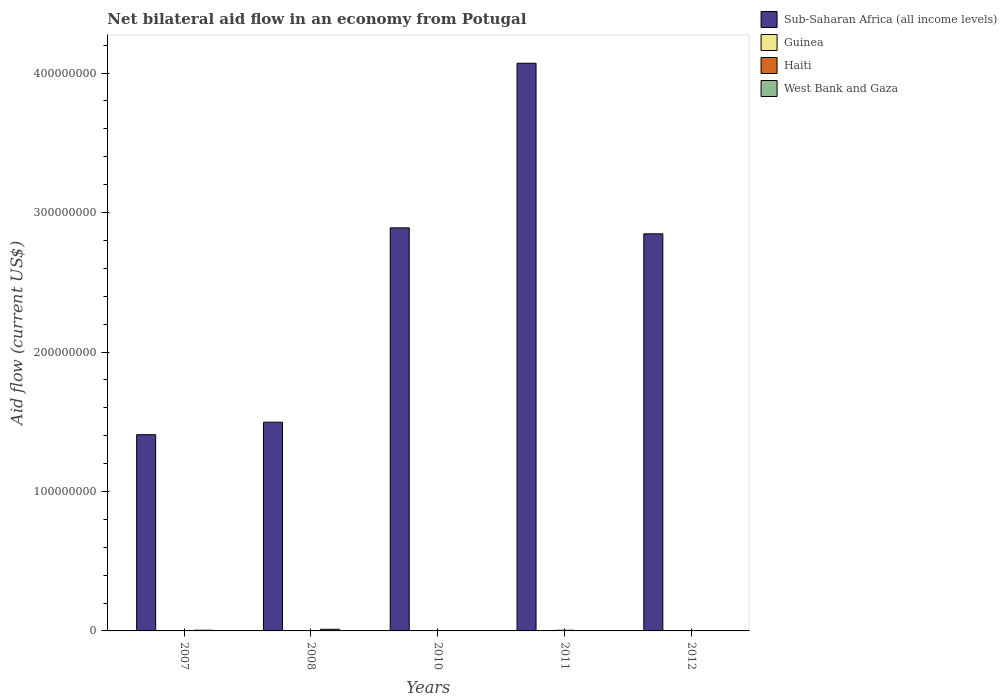How many different coloured bars are there?
Your answer should be very brief. 4. What is the label of the 3rd group of bars from the left?
Your response must be concise. 2010. In how many cases, is the number of bars for a given year not equal to the number of legend labels?
Give a very brief answer. 0. What is the net bilateral aid flow in Guinea in 2010?
Make the answer very short. 4.00e+04. Across all years, what is the minimum net bilateral aid flow in Sub-Saharan Africa (all income levels)?
Offer a terse response. 1.41e+08. In which year was the net bilateral aid flow in West Bank and Gaza minimum?
Ensure brevity in your answer.  2010. What is the total net bilateral aid flow in Haiti in the graph?
Offer a terse response. 9.40e+05. What is the difference between the net bilateral aid flow in Sub-Saharan Africa (all income levels) in 2011 and that in 2012?
Provide a succinct answer. 1.22e+08. What is the difference between the net bilateral aid flow in Haiti in 2011 and the net bilateral aid flow in Sub-Saharan Africa (all income levels) in 2010?
Provide a short and direct response. -2.89e+08. What is the average net bilateral aid flow in Haiti per year?
Offer a very short reply. 1.88e+05. In the year 2010, what is the difference between the net bilateral aid flow in Guinea and net bilateral aid flow in Sub-Saharan Africa (all income levels)?
Provide a succinct answer. -2.89e+08. In how many years, is the net bilateral aid flow in Sub-Saharan Africa (all income levels) greater than 200000000 US$?
Make the answer very short. 3. What is the ratio of the net bilateral aid flow in Guinea in 2010 to that in 2011?
Keep it short and to the point. 0.31. Is the net bilateral aid flow in Guinea in 2007 less than that in 2012?
Offer a terse response. Yes. Is the difference between the net bilateral aid flow in Guinea in 2008 and 2011 greater than the difference between the net bilateral aid flow in Sub-Saharan Africa (all income levels) in 2008 and 2011?
Give a very brief answer. Yes. What is the difference between the highest and the second highest net bilateral aid flow in Guinea?
Offer a terse response. 5.00e+04. What is the difference between the highest and the lowest net bilateral aid flow in West Bank and Gaza?
Keep it short and to the point. 1.18e+06. In how many years, is the net bilateral aid flow in Sub-Saharan Africa (all income levels) greater than the average net bilateral aid flow in Sub-Saharan Africa (all income levels) taken over all years?
Give a very brief answer. 3. Is it the case that in every year, the sum of the net bilateral aid flow in Guinea and net bilateral aid flow in West Bank and Gaza is greater than the sum of net bilateral aid flow in Sub-Saharan Africa (all income levels) and net bilateral aid flow in Haiti?
Ensure brevity in your answer.  No. What does the 1st bar from the left in 2011 represents?
Give a very brief answer. Sub-Saharan Africa (all income levels). What does the 2nd bar from the right in 2010 represents?
Provide a short and direct response. Haiti. Is it the case that in every year, the sum of the net bilateral aid flow in Haiti and net bilateral aid flow in West Bank and Gaza is greater than the net bilateral aid flow in Sub-Saharan Africa (all income levels)?
Make the answer very short. No. How many bars are there?
Your response must be concise. 20. Are all the bars in the graph horizontal?
Offer a very short reply. No. Are the values on the major ticks of Y-axis written in scientific E-notation?
Keep it short and to the point. No. Where does the legend appear in the graph?
Your answer should be very brief. Top right. What is the title of the graph?
Give a very brief answer. Net bilateral aid flow in an economy from Potugal. What is the label or title of the Y-axis?
Make the answer very short. Aid flow (current US$). What is the Aid flow (current US$) in Sub-Saharan Africa (all income levels) in 2007?
Offer a very short reply. 1.41e+08. What is the Aid flow (current US$) of Guinea in 2007?
Your response must be concise. 8.00e+04. What is the Aid flow (current US$) in Haiti in 2007?
Your answer should be compact. 1.70e+05. What is the Aid flow (current US$) of West Bank and Gaza in 2007?
Your response must be concise. 4.90e+05. What is the Aid flow (current US$) in Sub-Saharan Africa (all income levels) in 2008?
Offer a very short reply. 1.50e+08. What is the Aid flow (current US$) of Guinea in 2008?
Offer a very short reply. 4.00e+04. What is the Aid flow (current US$) in West Bank and Gaza in 2008?
Keep it short and to the point. 1.19e+06. What is the Aid flow (current US$) of Sub-Saharan Africa (all income levels) in 2010?
Provide a short and direct response. 2.89e+08. What is the Aid flow (current US$) of Sub-Saharan Africa (all income levels) in 2011?
Your answer should be compact. 4.07e+08. What is the Aid flow (current US$) in Haiti in 2011?
Offer a very short reply. 4.70e+05. What is the Aid flow (current US$) in West Bank and Gaza in 2011?
Offer a terse response. 2.00e+04. What is the Aid flow (current US$) in Sub-Saharan Africa (all income levels) in 2012?
Provide a succinct answer. 2.85e+08. What is the Aid flow (current US$) of Guinea in 2012?
Your answer should be compact. 1.80e+05. What is the Aid flow (current US$) in Haiti in 2012?
Give a very brief answer. 10000. What is the Aid flow (current US$) of West Bank and Gaza in 2012?
Offer a very short reply. 10000. Across all years, what is the maximum Aid flow (current US$) of Sub-Saharan Africa (all income levels)?
Offer a terse response. 4.07e+08. Across all years, what is the maximum Aid flow (current US$) of Guinea?
Ensure brevity in your answer.  1.80e+05. Across all years, what is the maximum Aid flow (current US$) of West Bank and Gaza?
Give a very brief answer. 1.19e+06. Across all years, what is the minimum Aid flow (current US$) in Sub-Saharan Africa (all income levels)?
Provide a short and direct response. 1.41e+08. Across all years, what is the minimum Aid flow (current US$) in Guinea?
Provide a succinct answer. 4.00e+04. Across all years, what is the minimum Aid flow (current US$) in Haiti?
Offer a terse response. 10000. Across all years, what is the minimum Aid flow (current US$) in West Bank and Gaza?
Your response must be concise. 10000. What is the total Aid flow (current US$) of Sub-Saharan Africa (all income levels) in the graph?
Provide a succinct answer. 1.27e+09. What is the total Aid flow (current US$) in Guinea in the graph?
Provide a short and direct response. 4.70e+05. What is the total Aid flow (current US$) in Haiti in the graph?
Give a very brief answer. 9.40e+05. What is the total Aid flow (current US$) of West Bank and Gaza in the graph?
Your answer should be compact. 1.72e+06. What is the difference between the Aid flow (current US$) of Sub-Saharan Africa (all income levels) in 2007 and that in 2008?
Give a very brief answer. -8.95e+06. What is the difference between the Aid flow (current US$) of Guinea in 2007 and that in 2008?
Your answer should be very brief. 4.00e+04. What is the difference between the Aid flow (current US$) of West Bank and Gaza in 2007 and that in 2008?
Your response must be concise. -7.00e+05. What is the difference between the Aid flow (current US$) of Sub-Saharan Africa (all income levels) in 2007 and that in 2010?
Give a very brief answer. -1.48e+08. What is the difference between the Aid flow (current US$) of Guinea in 2007 and that in 2010?
Make the answer very short. 4.00e+04. What is the difference between the Aid flow (current US$) in Sub-Saharan Africa (all income levels) in 2007 and that in 2011?
Offer a very short reply. -2.66e+08. What is the difference between the Aid flow (current US$) in West Bank and Gaza in 2007 and that in 2011?
Ensure brevity in your answer.  4.70e+05. What is the difference between the Aid flow (current US$) in Sub-Saharan Africa (all income levels) in 2007 and that in 2012?
Your answer should be compact. -1.44e+08. What is the difference between the Aid flow (current US$) in Haiti in 2007 and that in 2012?
Keep it short and to the point. 1.60e+05. What is the difference between the Aid flow (current US$) in Sub-Saharan Africa (all income levels) in 2008 and that in 2010?
Ensure brevity in your answer.  -1.39e+08. What is the difference between the Aid flow (current US$) of Guinea in 2008 and that in 2010?
Make the answer very short. 0. What is the difference between the Aid flow (current US$) in Haiti in 2008 and that in 2010?
Provide a short and direct response. 7.00e+04. What is the difference between the Aid flow (current US$) of West Bank and Gaza in 2008 and that in 2010?
Make the answer very short. 1.18e+06. What is the difference between the Aid flow (current US$) of Sub-Saharan Africa (all income levels) in 2008 and that in 2011?
Make the answer very short. -2.57e+08. What is the difference between the Aid flow (current US$) of Haiti in 2008 and that in 2011?
Provide a short and direct response. -2.90e+05. What is the difference between the Aid flow (current US$) in West Bank and Gaza in 2008 and that in 2011?
Offer a very short reply. 1.17e+06. What is the difference between the Aid flow (current US$) in Sub-Saharan Africa (all income levels) in 2008 and that in 2012?
Make the answer very short. -1.35e+08. What is the difference between the Aid flow (current US$) in Guinea in 2008 and that in 2012?
Your response must be concise. -1.40e+05. What is the difference between the Aid flow (current US$) in Haiti in 2008 and that in 2012?
Your answer should be compact. 1.70e+05. What is the difference between the Aid flow (current US$) of West Bank and Gaza in 2008 and that in 2012?
Your answer should be compact. 1.18e+06. What is the difference between the Aid flow (current US$) of Sub-Saharan Africa (all income levels) in 2010 and that in 2011?
Provide a succinct answer. -1.18e+08. What is the difference between the Aid flow (current US$) in Haiti in 2010 and that in 2011?
Make the answer very short. -3.60e+05. What is the difference between the Aid flow (current US$) of West Bank and Gaza in 2010 and that in 2011?
Keep it short and to the point. -10000. What is the difference between the Aid flow (current US$) in Sub-Saharan Africa (all income levels) in 2010 and that in 2012?
Ensure brevity in your answer.  4.27e+06. What is the difference between the Aid flow (current US$) of Haiti in 2010 and that in 2012?
Provide a succinct answer. 1.00e+05. What is the difference between the Aid flow (current US$) of Sub-Saharan Africa (all income levels) in 2011 and that in 2012?
Your answer should be very brief. 1.22e+08. What is the difference between the Aid flow (current US$) of Guinea in 2011 and that in 2012?
Provide a succinct answer. -5.00e+04. What is the difference between the Aid flow (current US$) of Haiti in 2011 and that in 2012?
Your answer should be compact. 4.60e+05. What is the difference between the Aid flow (current US$) in Sub-Saharan Africa (all income levels) in 2007 and the Aid flow (current US$) in Guinea in 2008?
Offer a very short reply. 1.41e+08. What is the difference between the Aid flow (current US$) in Sub-Saharan Africa (all income levels) in 2007 and the Aid flow (current US$) in Haiti in 2008?
Your answer should be very brief. 1.41e+08. What is the difference between the Aid flow (current US$) in Sub-Saharan Africa (all income levels) in 2007 and the Aid flow (current US$) in West Bank and Gaza in 2008?
Offer a terse response. 1.40e+08. What is the difference between the Aid flow (current US$) of Guinea in 2007 and the Aid flow (current US$) of Haiti in 2008?
Offer a terse response. -1.00e+05. What is the difference between the Aid flow (current US$) in Guinea in 2007 and the Aid flow (current US$) in West Bank and Gaza in 2008?
Ensure brevity in your answer.  -1.11e+06. What is the difference between the Aid flow (current US$) of Haiti in 2007 and the Aid flow (current US$) of West Bank and Gaza in 2008?
Provide a short and direct response. -1.02e+06. What is the difference between the Aid flow (current US$) in Sub-Saharan Africa (all income levels) in 2007 and the Aid flow (current US$) in Guinea in 2010?
Give a very brief answer. 1.41e+08. What is the difference between the Aid flow (current US$) of Sub-Saharan Africa (all income levels) in 2007 and the Aid flow (current US$) of Haiti in 2010?
Your answer should be compact. 1.41e+08. What is the difference between the Aid flow (current US$) in Sub-Saharan Africa (all income levels) in 2007 and the Aid flow (current US$) in West Bank and Gaza in 2010?
Make the answer very short. 1.41e+08. What is the difference between the Aid flow (current US$) of Guinea in 2007 and the Aid flow (current US$) of Haiti in 2010?
Offer a very short reply. -3.00e+04. What is the difference between the Aid flow (current US$) of Sub-Saharan Africa (all income levels) in 2007 and the Aid flow (current US$) of Guinea in 2011?
Your answer should be compact. 1.41e+08. What is the difference between the Aid flow (current US$) of Sub-Saharan Africa (all income levels) in 2007 and the Aid flow (current US$) of Haiti in 2011?
Provide a short and direct response. 1.40e+08. What is the difference between the Aid flow (current US$) of Sub-Saharan Africa (all income levels) in 2007 and the Aid flow (current US$) of West Bank and Gaza in 2011?
Give a very brief answer. 1.41e+08. What is the difference between the Aid flow (current US$) in Guinea in 2007 and the Aid flow (current US$) in Haiti in 2011?
Ensure brevity in your answer.  -3.90e+05. What is the difference between the Aid flow (current US$) of Guinea in 2007 and the Aid flow (current US$) of West Bank and Gaza in 2011?
Offer a terse response. 6.00e+04. What is the difference between the Aid flow (current US$) of Sub-Saharan Africa (all income levels) in 2007 and the Aid flow (current US$) of Guinea in 2012?
Your response must be concise. 1.41e+08. What is the difference between the Aid flow (current US$) in Sub-Saharan Africa (all income levels) in 2007 and the Aid flow (current US$) in Haiti in 2012?
Your answer should be very brief. 1.41e+08. What is the difference between the Aid flow (current US$) of Sub-Saharan Africa (all income levels) in 2007 and the Aid flow (current US$) of West Bank and Gaza in 2012?
Offer a very short reply. 1.41e+08. What is the difference between the Aid flow (current US$) of Guinea in 2007 and the Aid flow (current US$) of Haiti in 2012?
Give a very brief answer. 7.00e+04. What is the difference between the Aid flow (current US$) in Haiti in 2007 and the Aid flow (current US$) in West Bank and Gaza in 2012?
Offer a very short reply. 1.60e+05. What is the difference between the Aid flow (current US$) in Sub-Saharan Africa (all income levels) in 2008 and the Aid flow (current US$) in Guinea in 2010?
Provide a succinct answer. 1.50e+08. What is the difference between the Aid flow (current US$) in Sub-Saharan Africa (all income levels) in 2008 and the Aid flow (current US$) in Haiti in 2010?
Ensure brevity in your answer.  1.50e+08. What is the difference between the Aid flow (current US$) in Sub-Saharan Africa (all income levels) in 2008 and the Aid flow (current US$) in West Bank and Gaza in 2010?
Your answer should be compact. 1.50e+08. What is the difference between the Aid flow (current US$) in Guinea in 2008 and the Aid flow (current US$) in West Bank and Gaza in 2010?
Your answer should be very brief. 3.00e+04. What is the difference between the Aid flow (current US$) of Sub-Saharan Africa (all income levels) in 2008 and the Aid flow (current US$) of Guinea in 2011?
Keep it short and to the point. 1.50e+08. What is the difference between the Aid flow (current US$) of Sub-Saharan Africa (all income levels) in 2008 and the Aid flow (current US$) of Haiti in 2011?
Provide a short and direct response. 1.49e+08. What is the difference between the Aid flow (current US$) of Sub-Saharan Africa (all income levels) in 2008 and the Aid flow (current US$) of West Bank and Gaza in 2011?
Offer a very short reply. 1.50e+08. What is the difference between the Aid flow (current US$) in Guinea in 2008 and the Aid flow (current US$) in Haiti in 2011?
Offer a very short reply. -4.30e+05. What is the difference between the Aid flow (current US$) in Guinea in 2008 and the Aid flow (current US$) in West Bank and Gaza in 2011?
Keep it short and to the point. 2.00e+04. What is the difference between the Aid flow (current US$) in Sub-Saharan Africa (all income levels) in 2008 and the Aid flow (current US$) in Guinea in 2012?
Provide a short and direct response. 1.49e+08. What is the difference between the Aid flow (current US$) in Sub-Saharan Africa (all income levels) in 2008 and the Aid flow (current US$) in Haiti in 2012?
Make the answer very short. 1.50e+08. What is the difference between the Aid flow (current US$) in Sub-Saharan Africa (all income levels) in 2008 and the Aid flow (current US$) in West Bank and Gaza in 2012?
Make the answer very short. 1.50e+08. What is the difference between the Aid flow (current US$) of Guinea in 2008 and the Aid flow (current US$) of Haiti in 2012?
Make the answer very short. 3.00e+04. What is the difference between the Aid flow (current US$) in Haiti in 2008 and the Aid flow (current US$) in West Bank and Gaza in 2012?
Give a very brief answer. 1.70e+05. What is the difference between the Aid flow (current US$) of Sub-Saharan Africa (all income levels) in 2010 and the Aid flow (current US$) of Guinea in 2011?
Keep it short and to the point. 2.89e+08. What is the difference between the Aid flow (current US$) in Sub-Saharan Africa (all income levels) in 2010 and the Aid flow (current US$) in Haiti in 2011?
Give a very brief answer. 2.89e+08. What is the difference between the Aid flow (current US$) of Sub-Saharan Africa (all income levels) in 2010 and the Aid flow (current US$) of West Bank and Gaza in 2011?
Ensure brevity in your answer.  2.89e+08. What is the difference between the Aid flow (current US$) of Guinea in 2010 and the Aid flow (current US$) of Haiti in 2011?
Provide a short and direct response. -4.30e+05. What is the difference between the Aid flow (current US$) of Sub-Saharan Africa (all income levels) in 2010 and the Aid flow (current US$) of Guinea in 2012?
Offer a terse response. 2.89e+08. What is the difference between the Aid flow (current US$) in Sub-Saharan Africa (all income levels) in 2010 and the Aid flow (current US$) in Haiti in 2012?
Keep it short and to the point. 2.89e+08. What is the difference between the Aid flow (current US$) of Sub-Saharan Africa (all income levels) in 2010 and the Aid flow (current US$) of West Bank and Gaza in 2012?
Keep it short and to the point. 2.89e+08. What is the difference between the Aid flow (current US$) of Guinea in 2010 and the Aid flow (current US$) of West Bank and Gaza in 2012?
Provide a succinct answer. 3.00e+04. What is the difference between the Aid flow (current US$) of Haiti in 2010 and the Aid flow (current US$) of West Bank and Gaza in 2012?
Offer a terse response. 1.00e+05. What is the difference between the Aid flow (current US$) of Sub-Saharan Africa (all income levels) in 2011 and the Aid flow (current US$) of Guinea in 2012?
Give a very brief answer. 4.07e+08. What is the difference between the Aid flow (current US$) of Sub-Saharan Africa (all income levels) in 2011 and the Aid flow (current US$) of Haiti in 2012?
Ensure brevity in your answer.  4.07e+08. What is the difference between the Aid flow (current US$) in Sub-Saharan Africa (all income levels) in 2011 and the Aid flow (current US$) in West Bank and Gaza in 2012?
Your answer should be compact. 4.07e+08. What is the average Aid flow (current US$) of Sub-Saharan Africa (all income levels) per year?
Keep it short and to the point. 2.54e+08. What is the average Aid flow (current US$) in Guinea per year?
Your answer should be compact. 9.40e+04. What is the average Aid flow (current US$) of Haiti per year?
Give a very brief answer. 1.88e+05. What is the average Aid flow (current US$) in West Bank and Gaza per year?
Offer a terse response. 3.44e+05. In the year 2007, what is the difference between the Aid flow (current US$) in Sub-Saharan Africa (all income levels) and Aid flow (current US$) in Guinea?
Provide a short and direct response. 1.41e+08. In the year 2007, what is the difference between the Aid flow (current US$) in Sub-Saharan Africa (all income levels) and Aid flow (current US$) in Haiti?
Keep it short and to the point. 1.41e+08. In the year 2007, what is the difference between the Aid flow (current US$) in Sub-Saharan Africa (all income levels) and Aid flow (current US$) in West Bank and Gaza?
Provide a short and direct response. 1.40e+08. In the year 2007, what is the difference between the Aid flow (current US$) in Guinea and Aid flow (current US$) in West Bank and Gaza?
Keep it short and to the point. -4.10e+05. In the year 2007, what is the difference between the Aid flow (current US$) in Haiti and Aid flow (current US$) in West Bank and Gaza?
Offer a terse response. -3.20e+05. In the year 2008, what is the difference between the Aid flow (current US$) in Sub-Saharan Africa (all income levels) and Aid flow (current US$) in Guinea?
Offer a very short reply. 1.50e+08. In the year 2008, what is the difference between the Aid flow (current US$) of Sub-Saharan Africa (all income levels) and Aid flow (current US$) of Haiti?
Provide a short and direct response. 1.49e+08. In the year 2008, what is the difference between the Aid flow (current US$) of Sub-Saharan Africa (all income levels) and Aid flow (current US$) of West Bank and Gaza?
Offer a very short reply. 1.48e+08. In the year 2008, what is the difference between the Aid flow (current US$) of Guinea and Aid flow (current US$) of West Bank and Gaza?
Your answer should be compact. -1.15e+06. In the year 2008, what is the difference between the Aid flow (current US$) in Haiti and Aid flow (current US$) in West Bank and Gaza?
Ensure brevity in your answer.  -1.01e+06. In the year 2010, what is the difference between the Aid flow (current US$) in Sub-Saharan Africa (all income levels) and Aid flow (current US$) in Guinea?
Offer a terse response. 2.89e+08. In the year 2010, what is the difference between the Aid flow (current US$) of Sub-Saharan Africa (all income levels) and Aid flow (current US$) of Haiti?
Provide a succinct answer. 2.89e+08. In the year 2010, what is the difference between the Aid flow (current US$) of Sub-Saharan Africa (all income levels) and Aid flow (current US$) of West Bank and Gaza?
Your answer should be compact. 2.89e+08. In the year 2011, what is the difference between the Aid flow (current US$) in Sub-Saharan Africa (all income levels) and Aid flow (current US$) in Guinea?
Provide a short and direct response. 4.07e+08. In the year 2011, what is the difference between the Aid flow (current US$) of Sub-Saharan Africa (all income levels) and Aid flow (current US$) of Haiti?
Offer a terse response. 4.07e+08. In the year 2011, what is the difference between the Aid flow (current US$) of Sub-Saharan Africa (all income levels) and Aid flow (current US$) of West Bank and Gaza?
Your answer should be compact. 4.07e+08. In the year 2011, what is the difference between the Aid flow (current US$) of Guinea and Aid flow (current US$) of Haiti?
Your response must be concise. -3.40e+05. In the year 2011, what is the difference between the Aid flow (current US$) in Guinea and Aid flow (current US$) in West Bank and Gaza?
Provide a succinct answer. 1.10e+05. In the year 2011, what is the difference between the Aid flow (current US$) of Haiti and Aid flow (current US$) of West Bank and Gaza?
Ensure brevity in your answer.  4.50e+05. In the year 2012, what is the difference between the Aid flow (current US$) in Sub-Saharan Africa (all income levels) and Aid flow (current US$) in Guinea?
Provide a short and direct response. 2.85e+08. In the year 2012, what is the difference between the Aid flow (current US$) in Sub-Saharan Africa (all income levels) and Aid flow (current US$) in Haiti?
Your answer should be compact. 2.85e+08. In the year 2012, what is the difference between the Aid flow (current US$) of Sub-Saharan Africa (all income levels) and Aid flow (current US$) of West Bank and Gaza?
Offer a terse response. 2.85e+08. In the year 2012, what is the difference between the Aid flow (current US$) of Guinea and Aid flow (current US$) of Haiti?
Your response must be concise. 1.70e+05. In the year 2012, what is the difference between the Aid flow (current US$) in Haiti and Aid flow (current US$) in West Bank and Gaza?
Make the answer very short. 0. What is the ratio of the Aid flow (current US$) of Sub-Saharan Africa (all income levels) in 2007 to that in 2008?
Offer a terse response. 0.94. What is the ratio of the Aid flow (current US$) in Guinea in 2007 to that in 2008?
Give a very brief answer. 2. What is the ratio of the Aid flow (current US$) in West Bank and Gaza in 2007 to that in 2008?
Ensure brevity in your answer.  0.41. What is the ratio of the Aid flow (current US$) in Sub-Saharan Africa (all income levels) in 2007 to that in 2010?
Give a very brief answer. 0.49. What is the ratio of the Aid flow (current US$) of Haiti in 2007 to that in 2010?
Your answer should be compact. 1.55. What is the ratio of the Aid flow (current US$) of Sub-Saharan Africa (all income levels) in 2007 to that in 2011?
Your answer should be very brief. 0.35. What is the ratio of the Aid flow (current US$) of Guinea in 2007 to that in 2011?
Offer a terse response. 0.62. What is the ratio of the Aid flow (current US$) of Haiti in 2007 to that in 2011?
Give a very brief answer. 0.36. What is the ratio of the Aid flow (current US$) in Sub-Saharan Africa (all income levels) in 2007 to that in 2012?
Offer a very short reply. 0.49. What is the ratio of the Aid flow (current US$) in Guinea in 2007 to that in 2012?
Keep it short and to the point. 0.44. What is the ratio of the Aid flow (current US$) in Sub-Saharan Africa (all income levels) in 2008 to that in 2010?
Ensure brevity in your answer.  0.52. What is the ratio of the Aid flow (current US$) in Guinea in 2008 to that in 2010?
Your response must be concise. 1. What is the ratio of the Aid flow (current US$) of Haiti in 2008 to that in 2010?
Ensure brevity in your answer.  1.64. What is the ratio of the Aid flow (current US$) of West Bank and Gaza in 2008 to that in 2010?
Make the answer very short. 119. What is the ratio of the Aid flow (current US$) in Sub-Saharan Africa (all income levels) in 2008 to that in 2011?
Offer a very short reply. 0.37. What is the ratio of the Aid flow (current US$) in Guinea in 2008 to that in 2011?
Give a very brief answer. 0.31. What is the ratio of the Aid flow (current US$) in Haiti in 2008 to that in 2011?
Give a very brief answer. 0.38. What is the ratio of the Aid flow (current US$) in West Bank and Gaza in 2008 to that in 2011?
Offer a very short reply. 59.5. What is the ratio of the Aid flow (current US$) of Sub-Saharan Africa (all income levels) in 2008 to that in 2012?
Your answer should be compact. 0.53. What is the ratio of the Aid flow (current US$) of Guinea in 2008 to that in 2012?
Your response must be concise. 0.22. What is the ratio of the Aid flow (current US$) in West Bank and Gaza in 2008 to that in 2012?
Offer a terse response. 119. What is the ratio of the Aid flow (current US$) of Sub-Saharan Africa (all income levels) in 2010 to that in 2011?
Offer a terse response. 0.71. What is the ratio of the Aid flow (current US$) of Guinea in 2010 to that in 2011?
Provide a short and direct response. 0.31. What is the ratio of the Aid flow (current US$) in Haiti in 2010 to that in 2011?
Your answer should be compact. 0.23. What is the ratio of the Aid flow (current US$) in West Bank and Gaza in 2010 to that in 2011?
Your response must be concise. 0.5. What is the ratio of the Aid flow (current US$) of Guinea in 2010 to that in 2012?
Your response must be concise. 0.22. What is the ratio of the Aid flow (current US$) in Haiti in 2010 to that in 2012?
Provide a short and direct response. 11. What is the ratio of the Aid flow (current US$) of West Bank and Gaza in 2010 to that in 2012?
Your response must be concise. 1. What is the ratio of the Aid flow (current US$) of Sub-Saharan Africa (all income levels) in 2011 to that in 2012?
Ensure brevity in your answer.  1.43. What is the ratio of the Aid flow (current US$) in Guinea in 2011 to that in 2012?
Offer a very short reply. 0.72. What is the ratio of the Aid flow (current US$) in West Bank and Gaza in 2011 to that in 2012?
Your answer should be very brief. 2. What is the difference between the highest and the second highest Aid flow (current US$) of Sub-Saharan Africa (all income levels)?
Ensure brevity in your answer.  1.18e+08. What is the difference between the highest and the second highest Aid flow (current US$) in Guinea?
Provide a short and direct response. 5.00e+04. What is the difference between the highest and the second highest Aid flow (current US$) in Haiti?
Ensure brevity in your answer.  2.90e+05. What is the difference between the highest and the lowest Aid flow (current US$) of Sub-Saharan Africa (all income levels)?
Give a very brief answer. 2.66e+08. What is the difference between the highest and the lowest Aid flow (current US$) of Guinea?
Make the answer very short. 1.40e+05. What is the difference between the highest and the lowest Aid flow (current US$) in Haiti?
Your answer should be compact. 4.60e+05. What is the difference between the highest and the lowest Aid flow (current US$) in West Bank and Gaza?
Ensure brevity in your answer.  1.18e+06. 